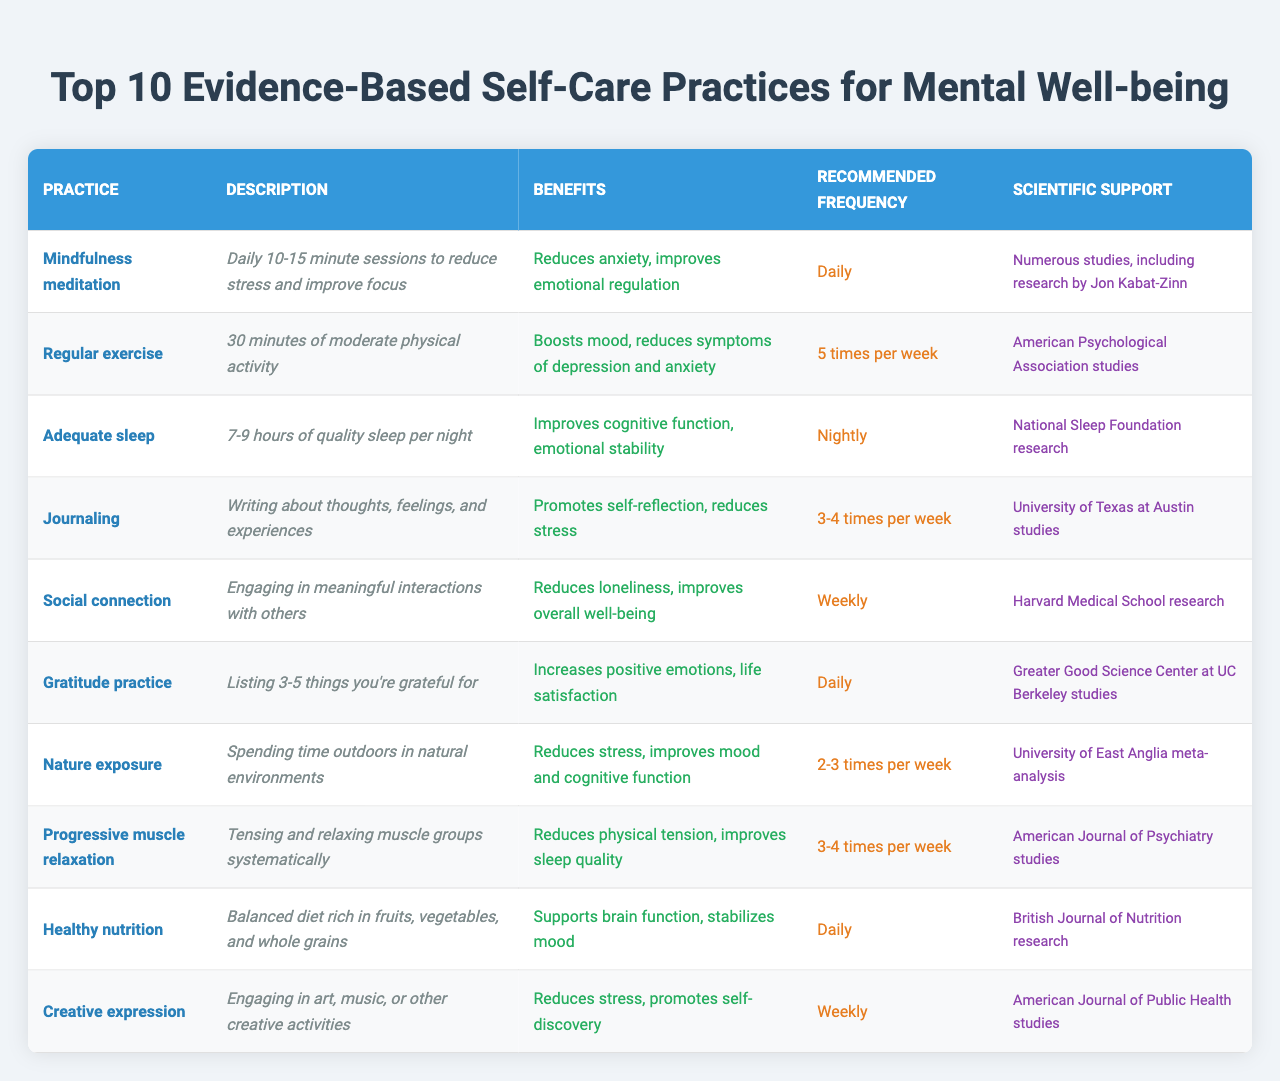What is the recommended frequency for practicing mindfulness meditation? The table indicates that mindfulness meditation should be practiced daily.
Answer: Daily Which self-care practice focuses on writing about thoughts and feelings? The self-care practice that focuses on this aspect is journaling, as described in the table.
Answer: Journaling How many hours of sleep are recommended for adequate sleep? According to the table, the recommended amount of sleep is between 7 to 9 hours per night.
Answer: 7-9 hours Is gratitude practice recommended more or less frequently than social connection? The table states that gratitude practice is done daily, while social connection is recommended weekly. Therefore, gratitude practice is recommended more frequently.
Answer: More frequently What are the benefits of engaging in regular exercise? The table notes that regular exercise boosts mood and reduces symptoms of depression and anxiety.
Answer: Boosts mood, reduces symptoms of depression and anxiety Which practice has scientific support from Harvard Medical School? The practice that has scientific support from Harvard Medical School is social connection, as referenced in the table.
Answer: Social connection How many times a week should one practice nature exposure? The table specifies that nature exposure should be practiced 2 to 3 times per week.
Answer: 2-3 times per week Which self-care practice has the least recommended frequency? By analyzing the frequencies listed in the table, social connection is practiced weekly, while others have daily or more frequent recommendations, making it the least frequent.
Answer: Social connection What benefits does journaling provide according to the table? The table indicates that journaling promotes self-reflection and reduces stress, highlighting the benefits associated with this practice.
Answer: Promotes self-reflection, reduces stress Are there any practices that are recommended both daily and 3-4 times per week? Yes, mindfulness meditation and gratitude practice are recommended daily, while journaling and progressive muscle relaxation are recommended 3-4 times per week, making it a mixed recommendation.
Answer: Yes, there are practices with different frequencies 